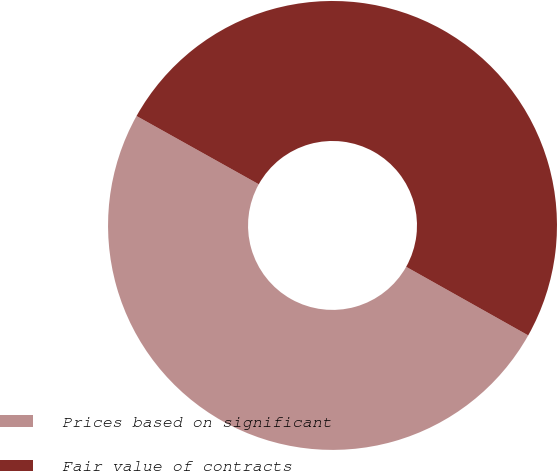Convert chart. <chart><loc_0><loc_0><loc_500><loc_500><pie_chart><fcel>Prices based on significant<fcel>Fair value of contracts<nl><fcel>49.96%<fcel>50.04%<nl></chart> 